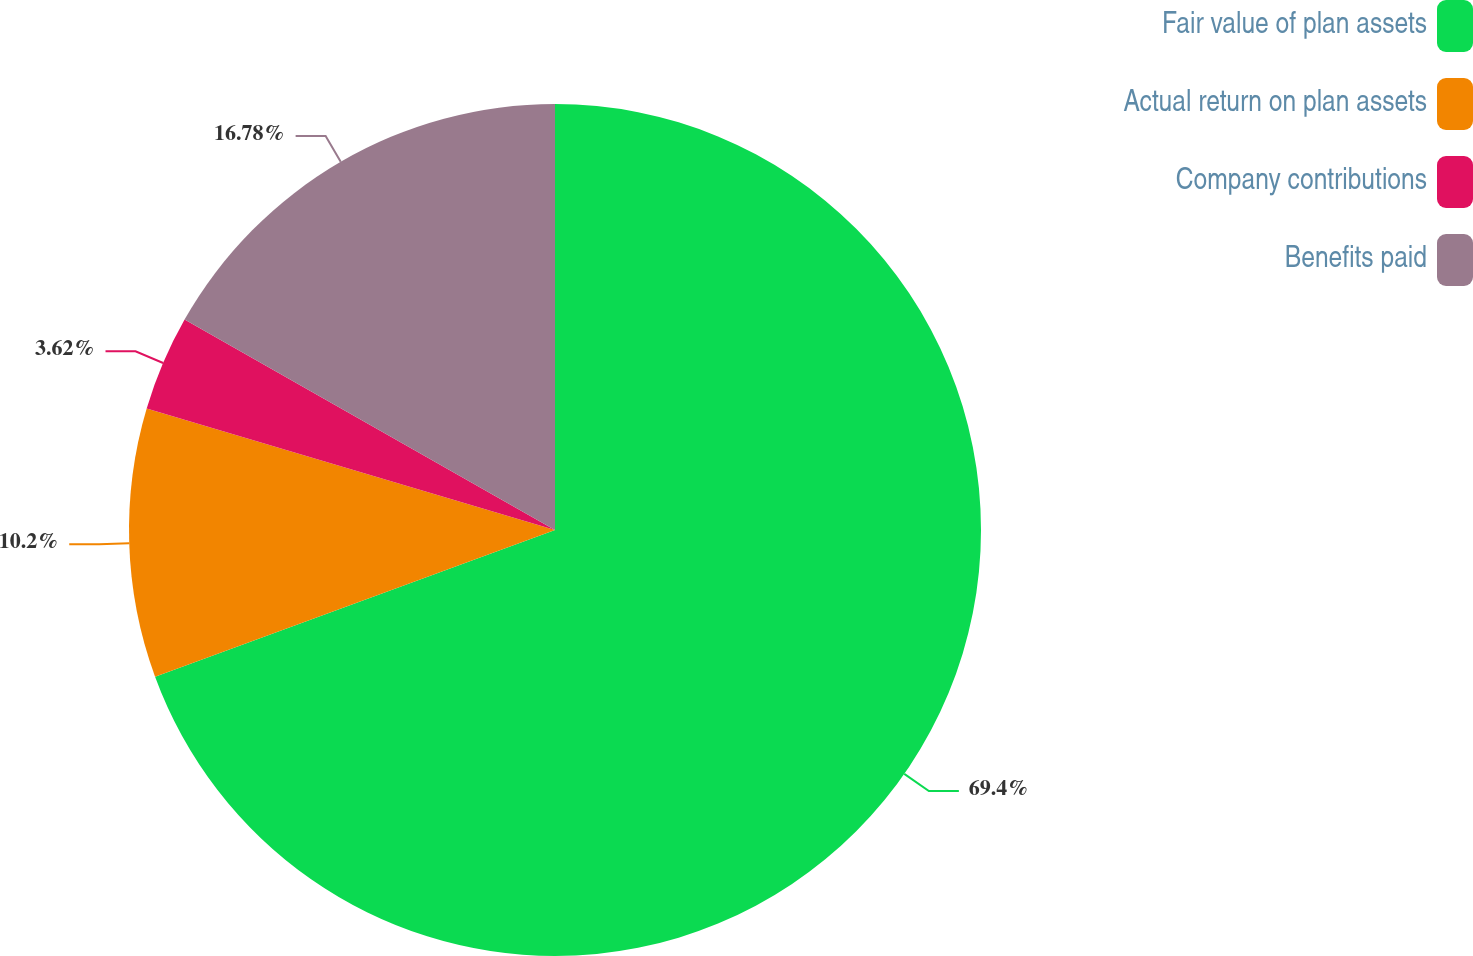Convert chart to OTSL. <chart><loc_0><loc_0><loc_500><loc_500><pie_chart><fcel>Fair value of plan assets<fcel>Actual return on plan assets<fcel>Company contributions<fcel>Benefits paid<nl><fcel>69.41%<fcel>10.2%<fcel>3.62%<fcel>16.78%<nl></chart> 